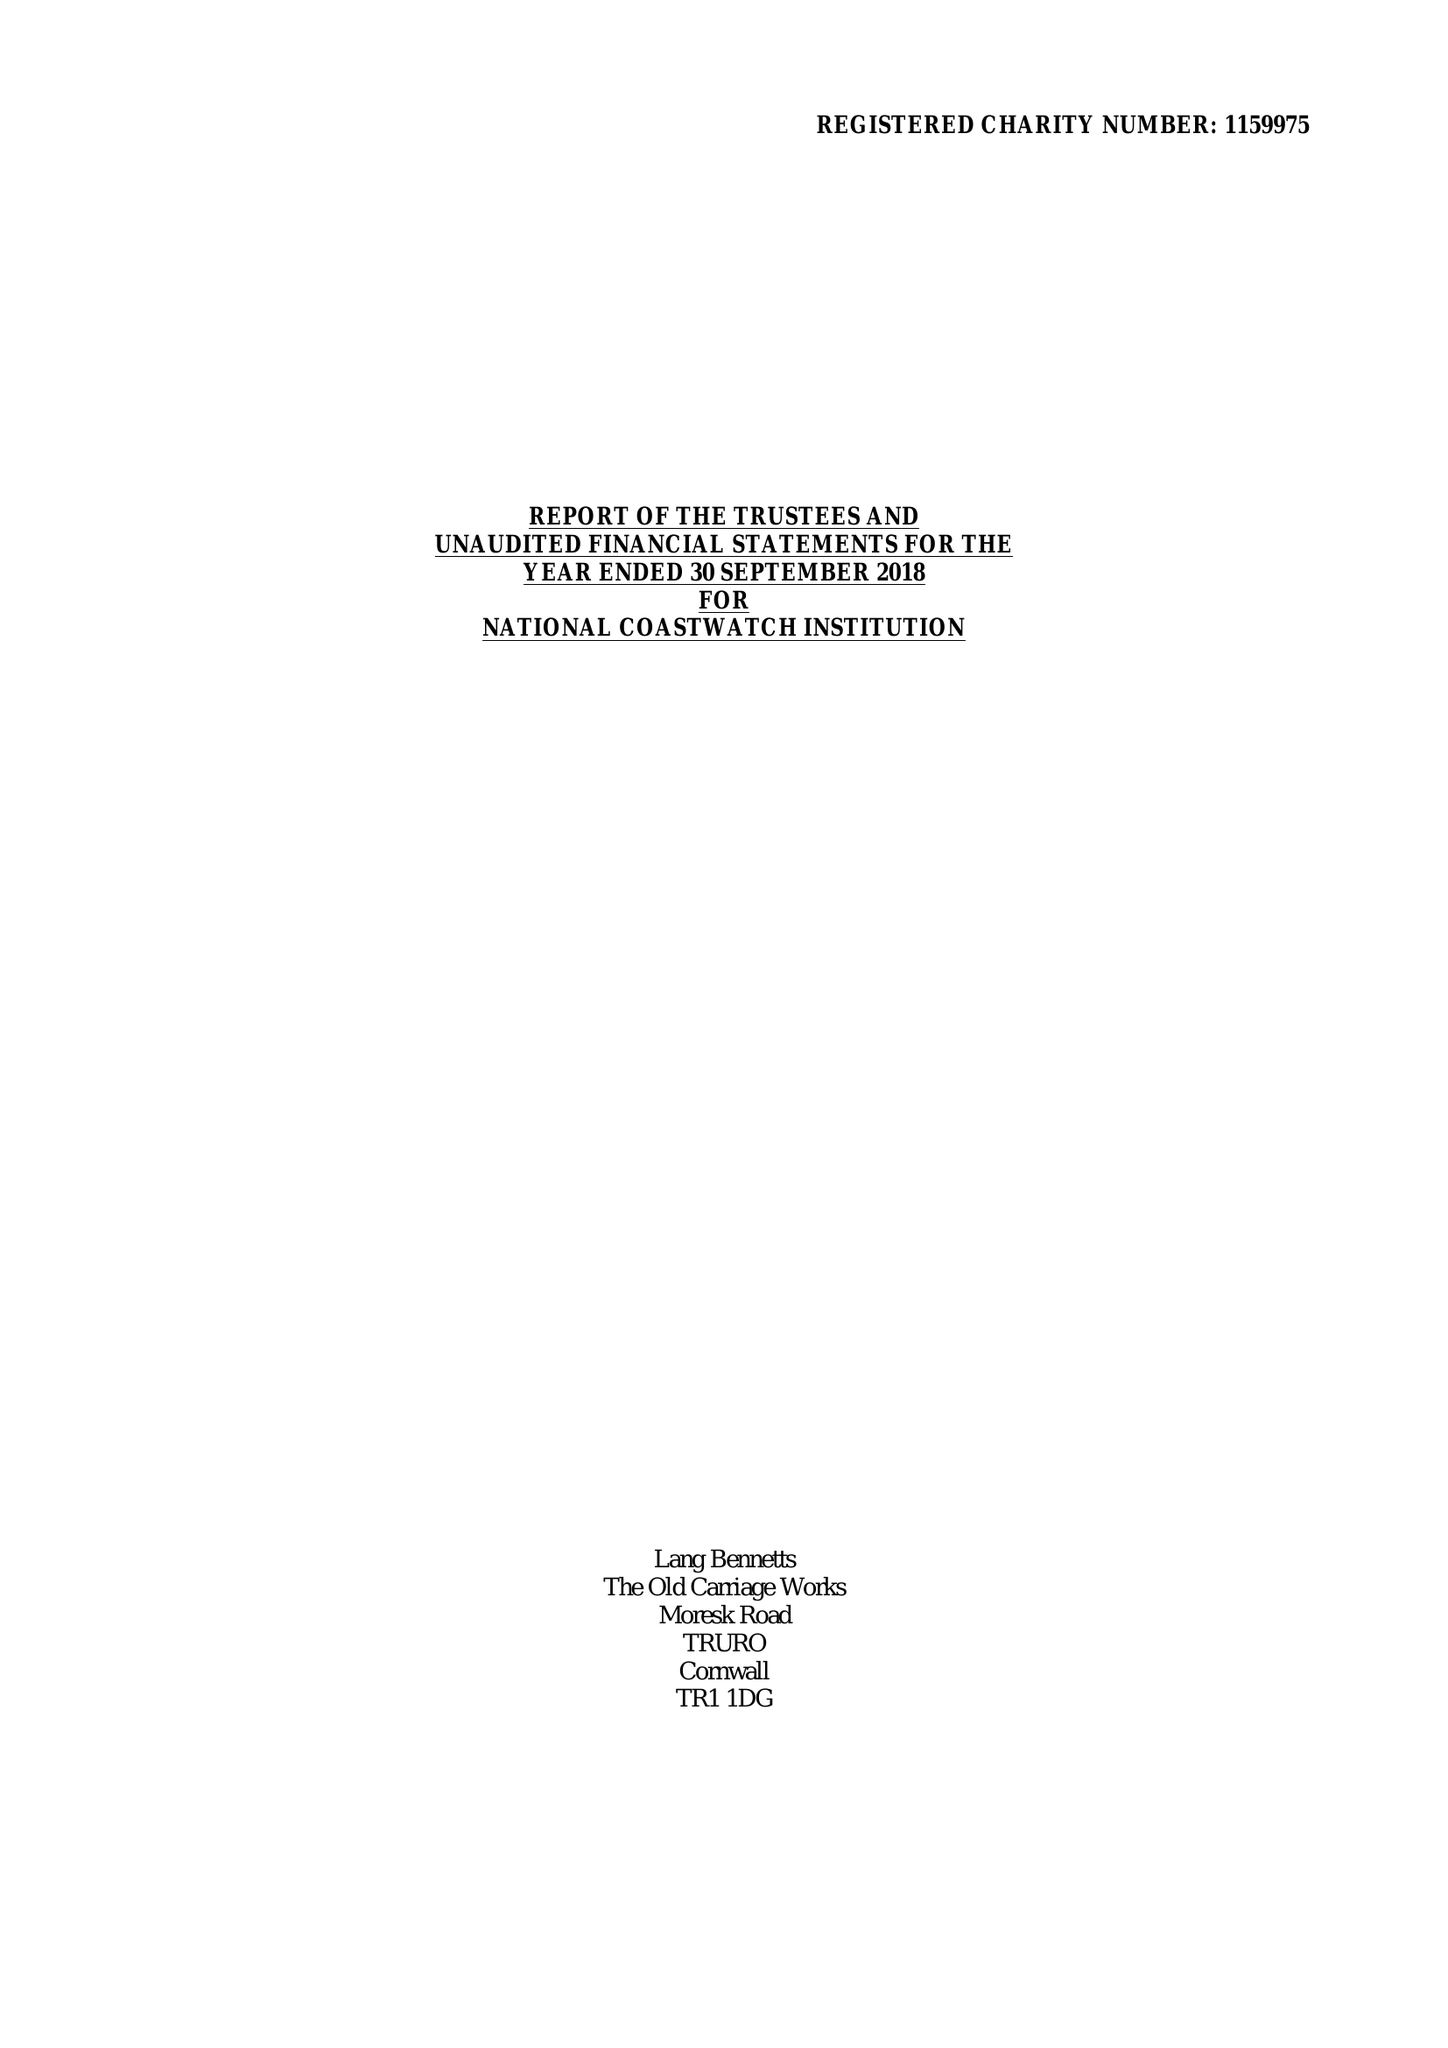What is the value for the spending_annually_in_british_pounds?
Answer the question using a single word or phrase. 501460.00 